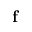<formula> <loc_0><loc_0><loc_500><loc_500>f</formula> 